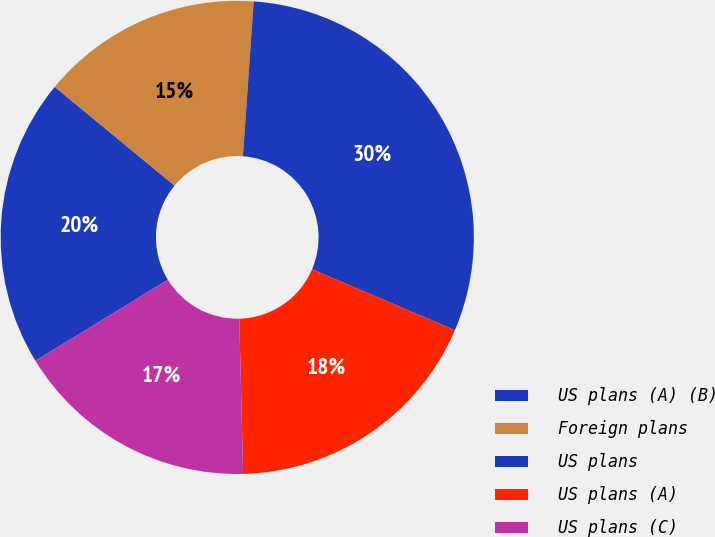Convert chart to OTSL. <chart><loc_0><loc_0><loc_500><loc_500><pie_chart><fcel>US plans (A) (B)<fcel>Foreign plans<fcel>US plans<fcel>US plans (A)<fcel>US plans (C)<nl><fcel>19.71%<fcel>15.13%<fcel>30.31%<fcel>18.19%<fcel>16.66%<nl></chart> 